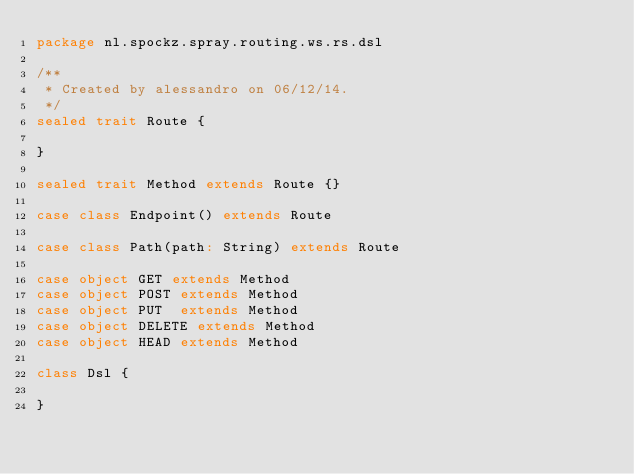<code> <loc_0><loc_0><loc_500><loc_500><_Scala_>package nl.spockz.spray.routing.ws.rs.dsl

/**
 * Created by alessandro on 06/12/14.
 */
sealed trait Route {

}

sealed trait Method extends Route {}

case class Endpoint() extends Route

case class Path(path: String) extends Route

case object GET extends Method
case object POST extends Method
case object PUT  extends Method
case object DELETE extends Method
case object HEAD extends Method

class Dsl {

}
</code> 